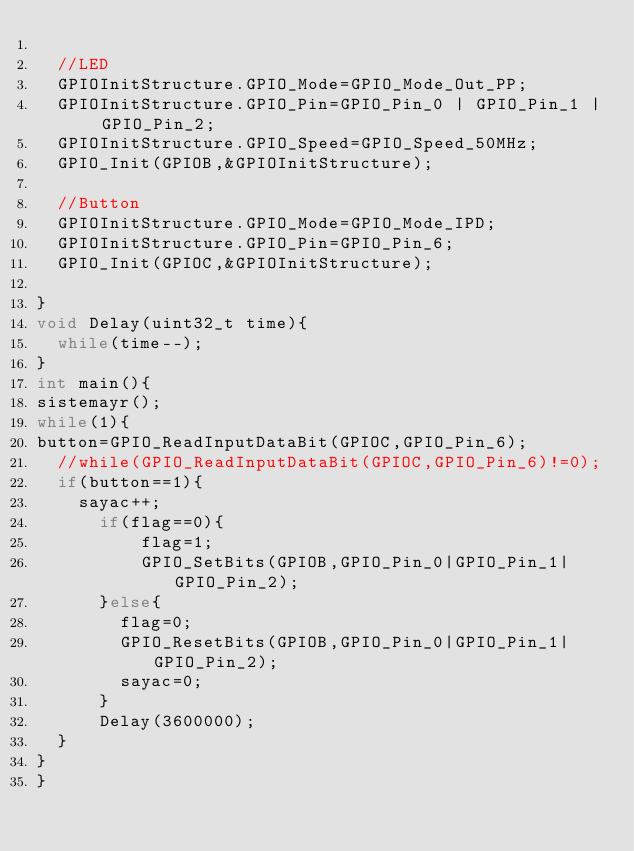Convert code to text. <code><loc_0><loc_0><loc_500><loc_500><_C_>	
	//LED
	GPIOInitStructure.GPIO_Mode=GPIO_Mode_Out_PP;
	GPIOInitStructure.GPIO_Pin=GPIO_Pin_0 | GPIO_Pin_1 | GPIO_Pin_2;
	GPIOInitStructure.GPIO_Speed=GPIO_Speed_50MHz;
	GPIO_Init(GPIOB,&GPIOInitStructure);
	
	//Button
	GPIOInitStructure.GPIO_Mode=GPIO_Mode_IPD;
	GPIOInitStructure.GPIO_Pin=GPIO_Pin_6;
	GPIO_Init(GPIOC,&GPIOInitStructure);

}
void Delay(uint32_t time){
	while(time--);
}
int main(){
sistemayr();
while(1){
button=GPIO_ReadInputDataBit(GPIOC,GPIO_Pin_6);
	//while(GPIO_ReadInputDataBit(GPIOC,GPIO_Pin_6)!=0);
	if(button==1){
		sayac++;
			if(flag==0){
					flag=1;
					GPIO_SetBits(GPIOB,GPIO_Pin_0|GPIO_Pin_1|GPIO_Pin_2);
			}else{
				flag=0;
				GPIO_ResetBits(GPIOB,GPIO_Pin_0|GPIO_Pin_1|GPIO_Pin_2);
				sayac=0;
			}
			Delay(3600000);
	}
}
}
</code> 